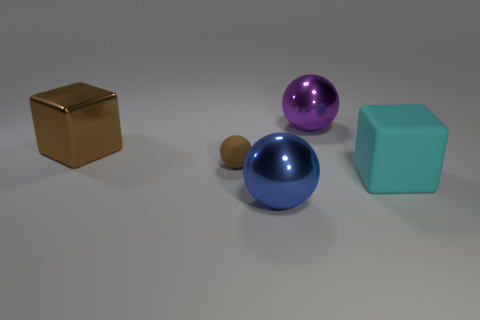Can you tell me what the material of the golden cube might be? The golden cube appears to have a reflective surface with a metallic luster, suggesting that it is designed to resemble a metal, perhaps gold or a gold-colored alloy. However, without additional context, it's not possible to determine the actual material from the image alone. 